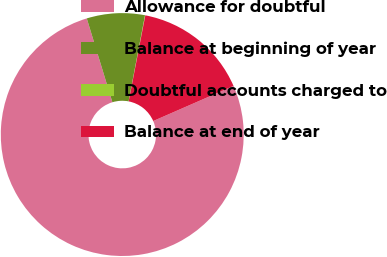<chart> <loc_0><loc_0><loc_500><loc_500><pie_chart><fcel>Allowance for doubtful<fcel>Balance at beginning of year<fcel>Doubtful accounts charged to<fcel>Balance at end of year<nl><fcel>76.84%<fcel>7.72%<fcel>0.04%<fcel>15.4%<nl></chart> 